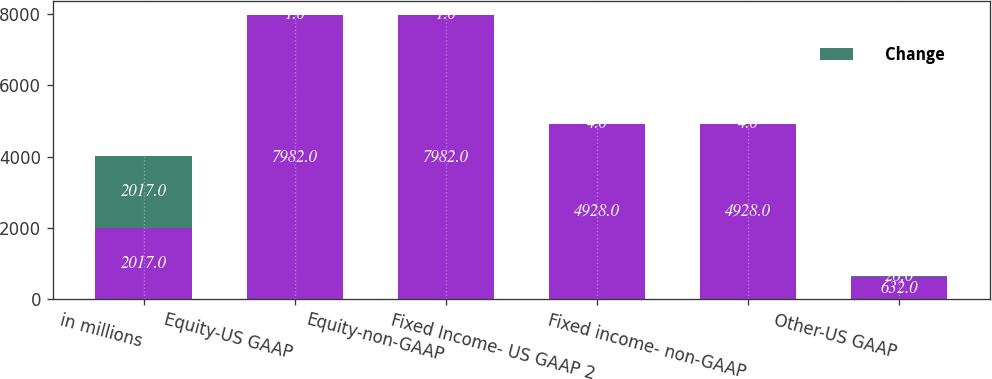<chart> <loc_0><loc_0><loc_500><loc_500><stacked_bar_chart><ecel><fcel>in millions<fcel>Equity-US GAAP<fcel>Equity-non-GAAP<fcel>Fixed Income- US GAAP 2<fcel>Fixed income- non-GAAP<fcel>Other-US GAAP<nl><fcel>nan<fcel>2017<fcel>7982<fcel>7982<fcel>4928<fcel>4928<fcel>632<nl><fcel>Change<fcel>2017<fcel>1<fcel>1<fcel>4<fcel>4<fcel>26<nl></chart> 